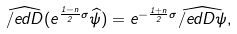<formula> <loc_0><loc_0><loc_500><loc_500>\widehat { \slash e d { D } } ( e ^ { \frac { 1 - n } { 2 } \sigma } \widehat { \psi } ) = e ^ { - \frac { 1 + n } { 2 } \sigma } \widehat { \slash e d { D } \psi } ,</formula> 